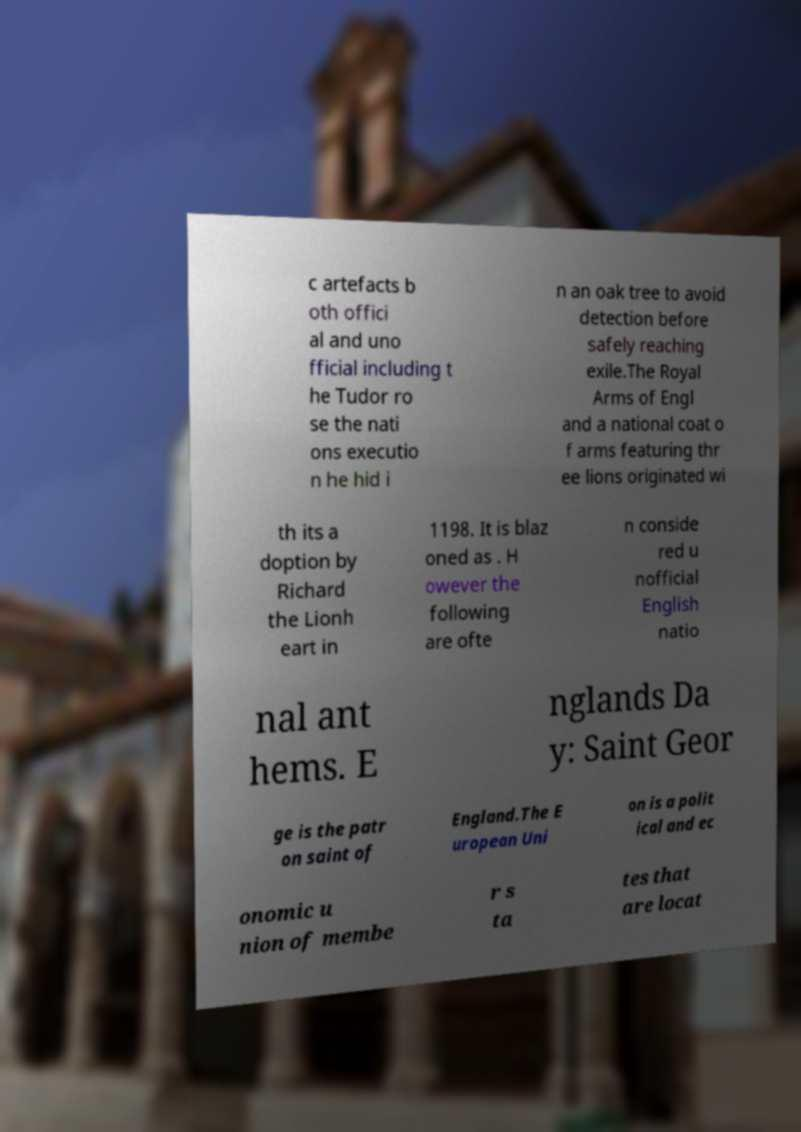Can you read and provide the text displayed in the image?This photo seems to have some interesting text. Can you extract and type it out for me? c artefacts b oth offici al and uno fficial including t he Tudor ro se the nati ons executio n he hid i n an oak tree to avoid detection before safely reaching exile.The Royal Arms of Engl and a national coat o f arms featuring thr ee lions originated wi th its a doption by Richard the Lionh eart in 1198. It is blaz oned as . H owever the following are ofte n conside red u nofficial English natio nal ant hems. E nglands Da y: Saint Geor ge is the patr on saint of England.The E uropean Uni on is a polit ical and ec onomic u nion of membe r s ta tes that are locat 